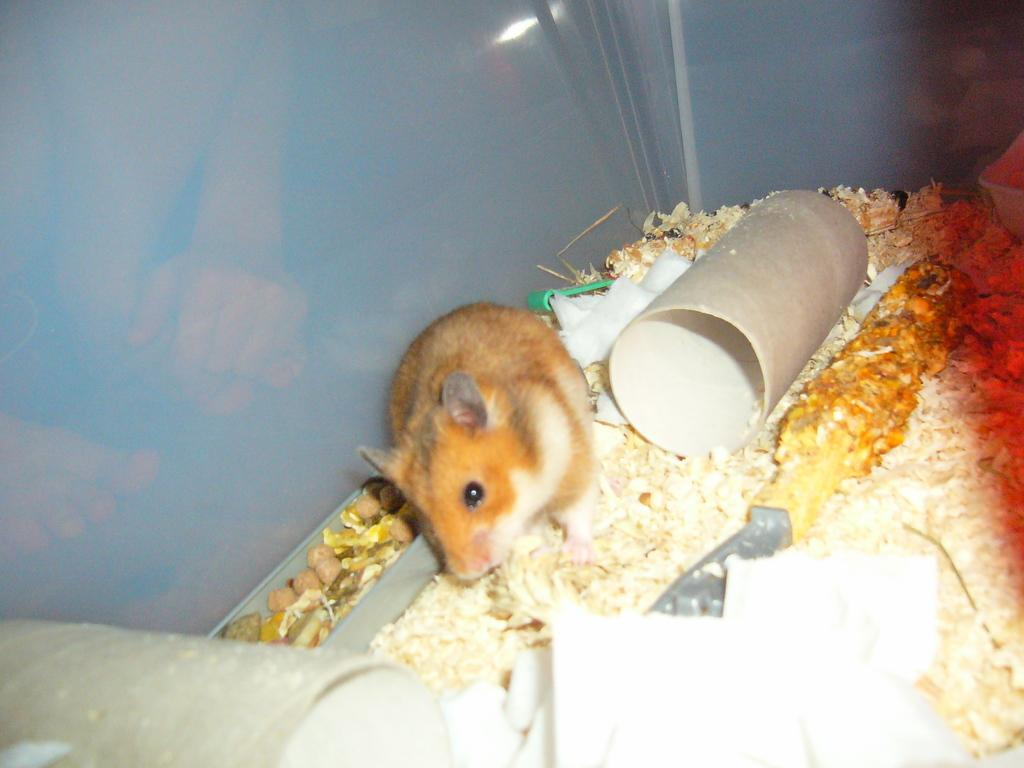What is the main subject in the center of the image? There is a rat in the center of the image. What can be seen in the background of the image? There is food for the rat in the background of the image. Can you describe any objects in the image based on their color? Yes, there are objects in the image that are cream and white in color. What type of wire is being used by the army in the image? There is no wire or army present in the image; it features a rat and food. How much salt is visible in the image? There is no salt visible in the image. 